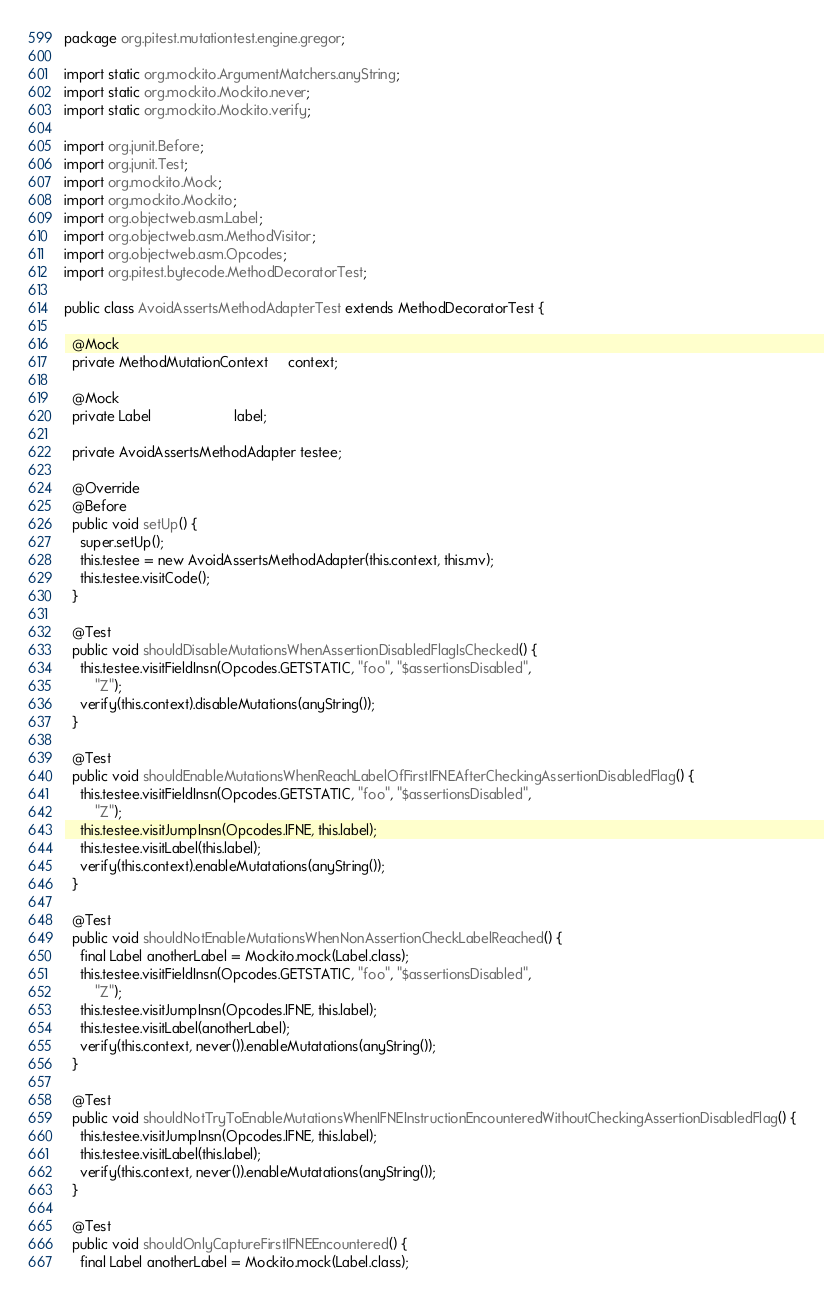<code> <loc_0><loc_0><loc_500><loc_500><_Java_>package org.pitest.mutationtest.engine.gregor;

import static org.mockito.ArgumentMatchers.anyString;
import static org.mockito.Mockito.never;
import static org.mockito.Mockito.verify;

import org.junit.Before;
import org.junit.Test;
import org.mockito.Mock;
import org.mockito.Mockito;
import org.objectweb.asm.Label;
import org.objectweb.asm.MethodVisitor;
import org.objectweb.asm.Opcodes;
import org.pitest.bytecode.MethodDecoratorTest;

public class AvoidAssertsMethodAdapterTest extends MethodDecoratorTest {

  @Mock
  private MethodMutationContext     context;

  @Mock
  private Label                     label;

  private AvoidAssertsMethodAdapter testee;

  @Override
  @Before
  public void setUp() {
    super.setUp();
    this.testee = new AvoidAssertsMethodAdapter(this.context, this.mv);
    this.testee.visitCode();
  }

  @Test
  public void shouldDisableMutationsWhenAssertionDisabledFlagIsChecked() {
    this.testee.visitFieldInsn(Opcodes.GETSTATIC, "foo", "$assertionsDisabled",
        "Z");
    verify(this.context).disableMutations(anyString());
  }

  @Test
  public void shouldEnableMutationsWhenReachLabelOfFirstIFNEAfterCheckingAssertionDisabledFlag() {
    this.testee.visitFieldInsn(Opcodes.GETSTATIC, "foo", "$assertionsDisabled",
        "Z");
    this.testee.visitJumpInsn(Opcodes.IFNE, this.label);
    this.testee.visitLabel(this.label);
    verify(this.context).enableMutatations(anyString());
  }

  @Test
  public void shouldNotEnableMutationsWhenNonAssertionCheckLabelReached() {
    final Label anotherLabel = Mockito.mock(Label.class);
    this.testee.visitFieldInsn(Opcodes.GETSTATIC, "foo", "$assertionsDisabled",
        "Z");
    this.testee.visitJumpInsn(Opcodes.IFNE, this.label);
    this.testee.visitLabel(anotherLabel);
    verify(this.context, never()).enableMutatations(anyString());
  }

  @Test
  public void shouldNotTryToEnableMutationsWhenIFNEInstructionEncounteredWithoutCheckingAssertionDisabledFlag() {
    this.testee.visitJumpInsn(Opcodes.IFNE, this.label);
    this.testee.visitLabel(this.label);
    verify(this.context, never()).enableMutatations(anyString());
  }

  @Test
  public void shouldOnlyCaptureFirstIFNEEncountered() {
    final Label anotherLabel = Mockito.mock(Label.class);</code> 